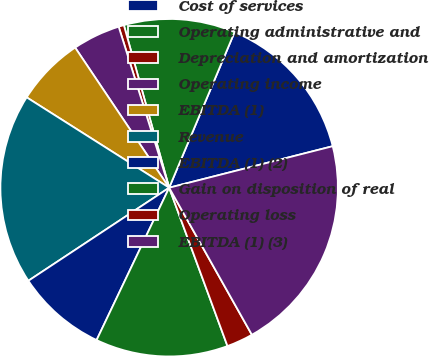Convert chart to OTSL. <chart><loc_0><loc_0><loc_500><loc_500><pie_chart><fcel>Cost of services<fcel>Operating administrative and<fcel>Depreciation and amortization<fcel>Operating income<fcel>EBITDA (1)<fcel>Revenue<fcel>EBITDA (1) (2)<fcel>Gain on disposition of real<fcel>Operating loss<fcel>EBITDA (1) (3)<nl><fcel>14.71%<fcel>10.66%<fcel>0.51%<fcel>4.57%<fcel>6.6%<fcel>18.29%<fcel>8.63%<fcel>12.69%<fcel>2.54%<fcel>20.8%<nl></chart> 